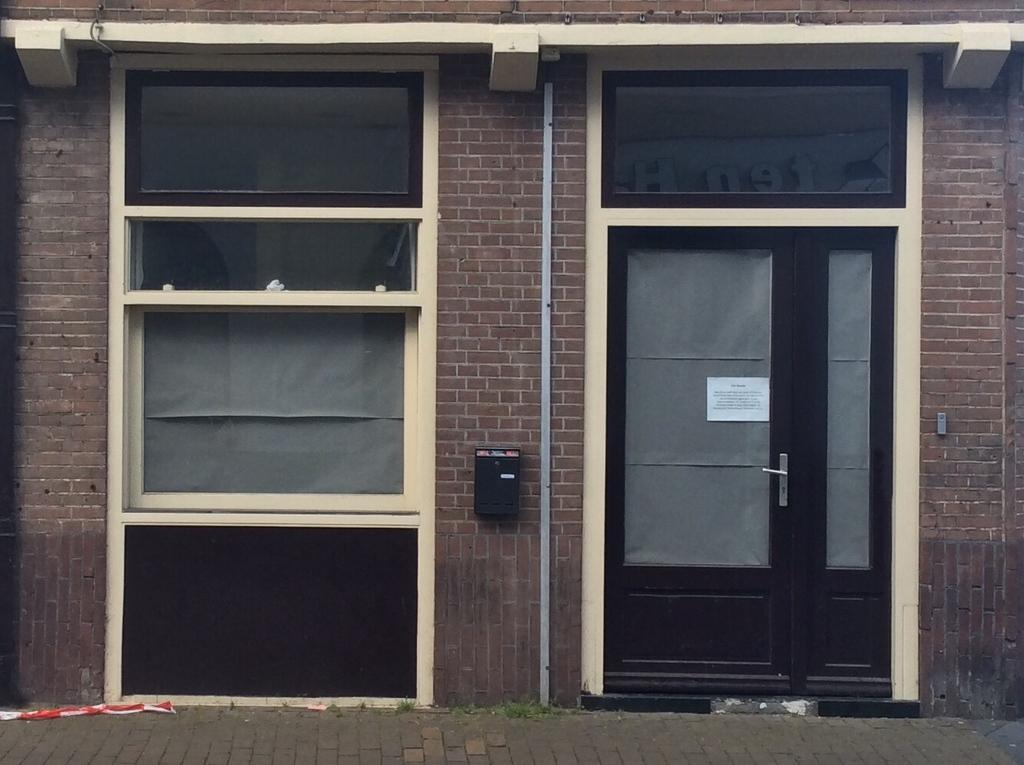What is the color of the wall in the image? The wall in the image is brown in color. What is located on the wall in the image? There is a brown color door on the wall in the image. Where is the door positioned on the wall? The door is on the wall in the image. What can be seen on the left side of the wall? There are windows on the left side of the wall in the image. What is visible in front of the wall? There is a path in front of the wall in the image. What type of knot is tied on the scarecrow in the image? There is no scarecrow present in the image, so there is no knot to be observed. What is the condition of the scarecrow in the image? There is no scarecrow present in the image, so its condition cannot be determined. 